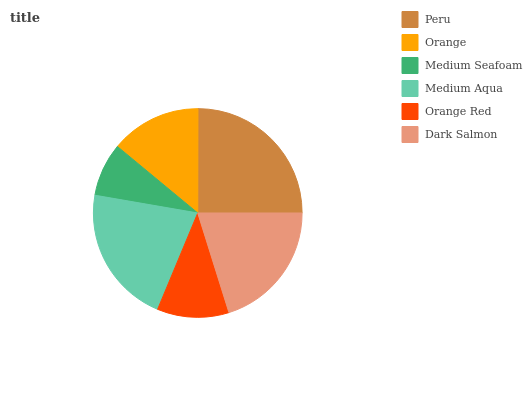Is Medium Seafoam the minimum?
Answer yes or no. Yes. Is Peru the maximum?
Answer yes or no. Yes. Is Orange the minimum?
Answer yes or no. No. Is Orange the maximum?
Answer yes or no. No. Is Peru greater than Orange?
Answer yes or no. Yes. Is Orange less than Peru?
Answer yes or no. Yes. Is Orange greater than Peru?
Answer yes or no. No. Is Peru less than Orange?
Answer yes or no. No. Is Dark Salmon the high median?
Answer yes or no. Yes. Is Orange the low median?
Answer yes or no. Yes. Is Peru the high median?
Answer yes or no. No. Is Dark Salmon the low median?
Answer yes or no. No. 